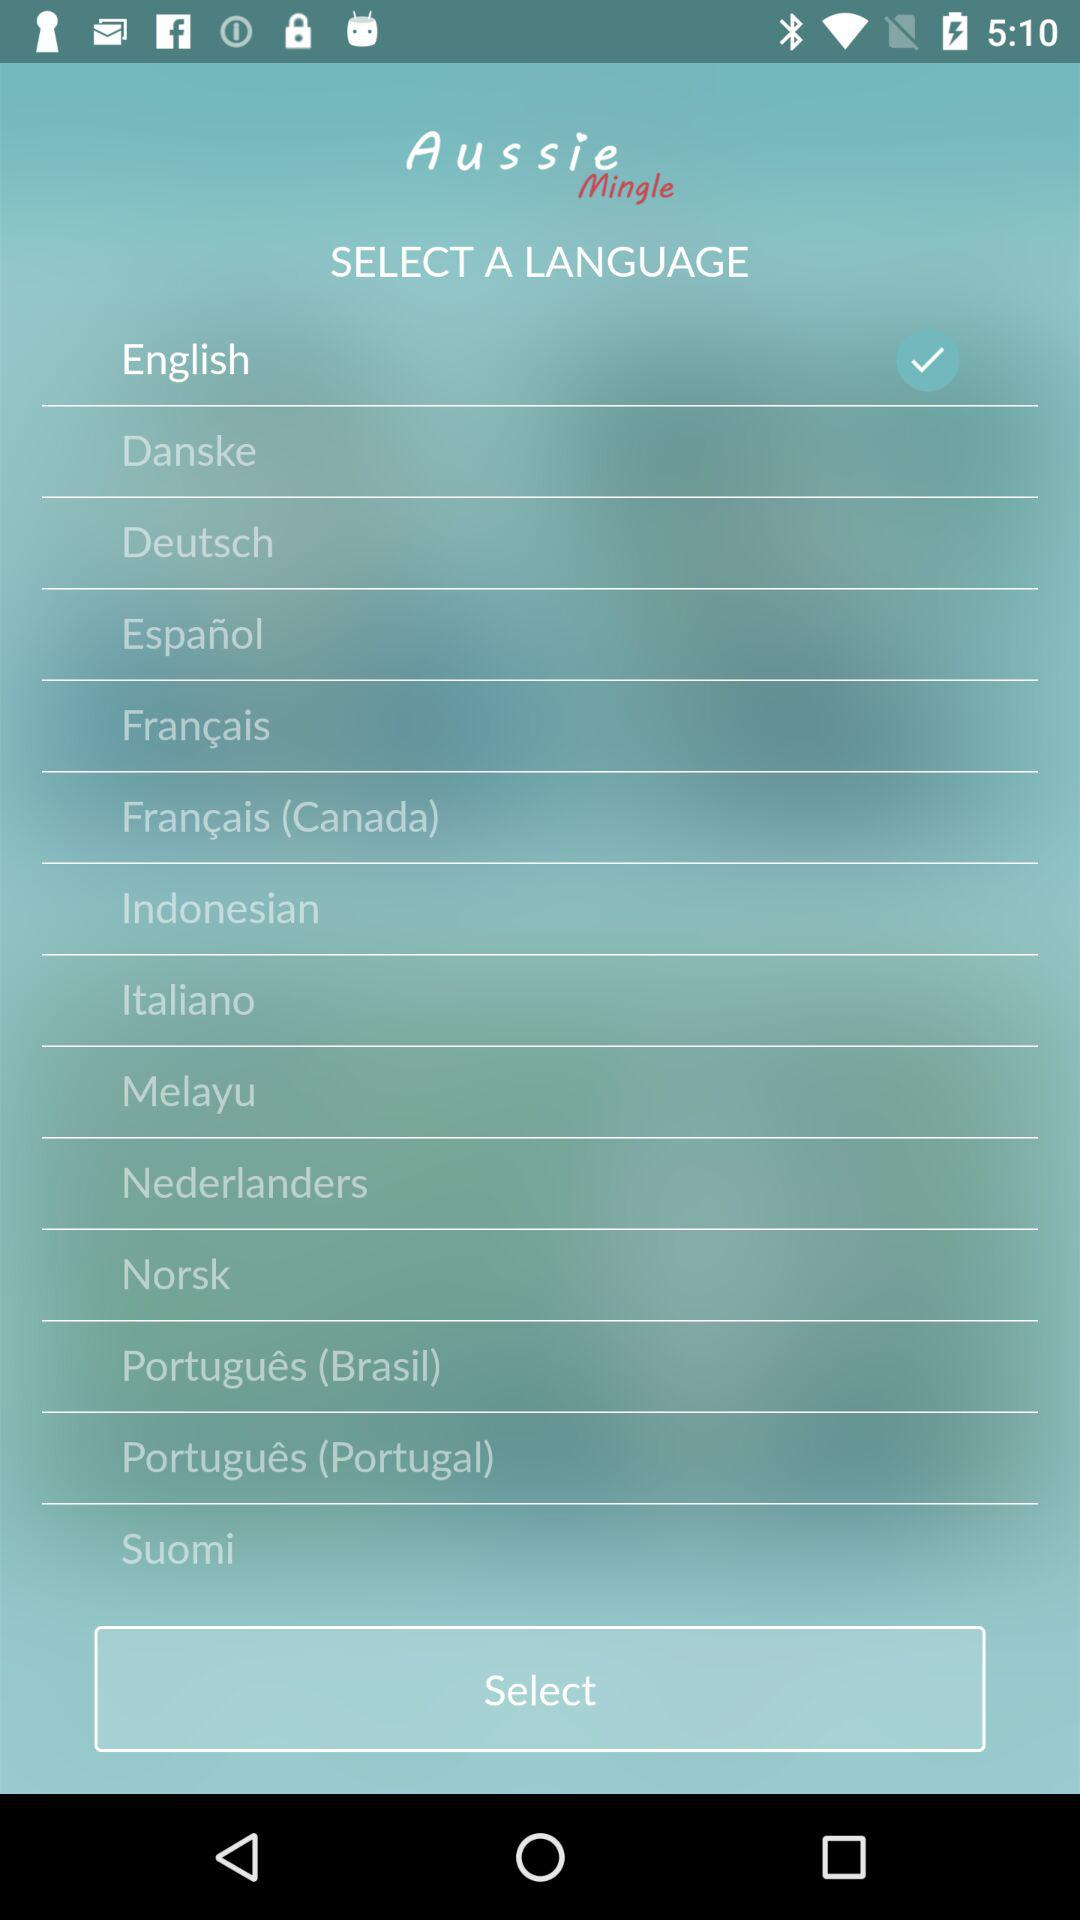Which language is selected? The selected language is English. 